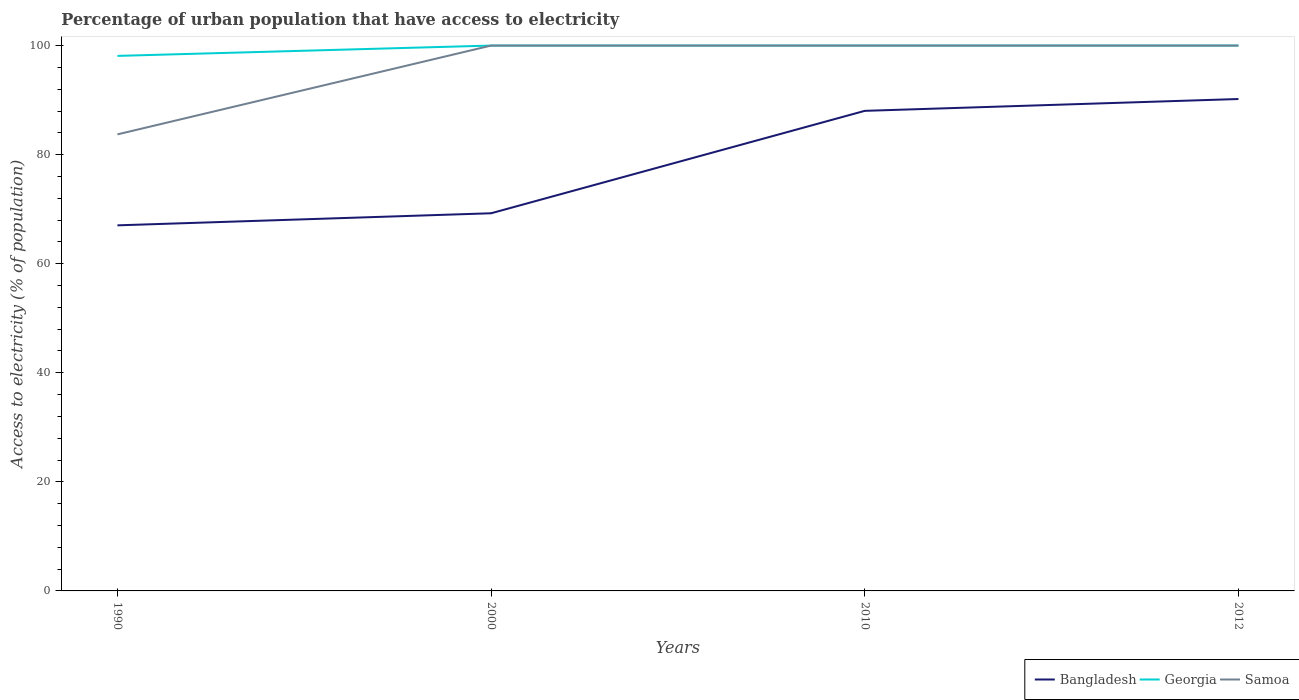How many different coloured lines are there?
Keep it short and to the point. 3. Does the line corresponding to Georgia intersect with the line corresponding to Samoa?
Offer a very short reply. Yes. Is the number of lines equal to the number of legend labels?
Ensure brevity in your answer.  Yes. Across all years, what is the maximum percentage of urban population that have access to electricity in Samoa?
Provide a succinct answer. 83.72. What is the total percentage of urban population that have access to electricity in Bangladesh in the graph?
Make the answer very short. -18.78. What is the difference between the highest and the second highest percentage of urban population that have access to electricity in Georgia?
Provide a succinct answer. 1.89. What is the difference between the highest and the lowest percentage of urban population that have access to electricity in Bangladesh?
Provide a succinct answer. 2. How many years are there in the graph?
Make the answer very short. 4. Does the graph contain any zero values?
Offer a very short reply. No. Where does the legend appear in the graph?
Offer a very short reply. Bottom right. How many legend labels are there?
Provide a short and direct response. 3. What is the title of the graph?
Offer a very short reply. Percentage of urban population that have access to electricity. Does "Channel Islands" appear as one of the legend labels in the graph?
Keep it short and to the point. No. What is the label or title of the X-axis?
Make the answer very short. Years. What is the label or title of the Y-axis?
Provide a short and direct response. Access to electricity (% of population). What is the Access to electricity (% of population) in Bangladesh in 1990?
Keep it short and to the point. 67.04. What is the Access to electricity (% of population) in Georgia in 1990?
Keep it short and to the point. 98.11. What is the Access to electricity (% of population) of Samoa in 1990?
Ensure brevity in your answer.  83.72. What is the Access to electricity (% of population) in Bangladesh in 2000?
Ensure brevity in your answer.  69.25. What is the Access to electricity (% of population) in Samoa in 2000?
Your response must be concise. 100. What is the Access to electricity (% of population) in Bangladesh in 2010?
Your answer should be compact. 88.03. What is the Access to electricity (% of population) of Bangladesh in 2012?
Keep it short and to the point. 90.2. What is the Access to electricity (% of population) in Samoa in 2012?
Ensure brevity in your answer.  100. Across all years, what is the maximum Access to electricity (% of population) of Bangladesh?
Your answer should be very brief. 90.2. Across all years, what is the maximum Access to electricity (% of population) of Georgia?
Give a very brief answer. 100. Across all years, what is the maximum Access to electricity (% of population) in Samoa?
Provide a succinct answer. 100. Across all years, what is the minimum Access to electricity (% of population) in Bangladesh?
Make the answer very short. 67.04. Across all years, what is the minimum Access to electricity (% of population) of Georgia?
Offer a terse response. 98.11. Across all years, what is the minimum Access to electricity (% of population) in Samoa?
Your response must be concise. 83.72. What is the total Access to electricity (% of population) of Bangladesh in the graph?
Give a very brief answer. 314.51. What is the total Access to electricity (% of population) in Georgia in the graph?
Keep it short and to the point. 398.11. What is the total Access to electricity (% of population) of Samoa in the graph?
Keep it short and to the point. 383.72. What is the difference between the Access to electricity (% of population) of Bangladesh in 1990 and that in 2000?
Your response must be concise. -2.21. What is the difference between the Access to electricity (% of population) of Georgia in 1990 and that in 2000?
Provide a succinct answer. -1.89. What is the difference between the Access to electricity (% of population) in Samoa in 1990 and that in 2000?
Make the answer very short. -16.28. What is the difference between the Access to electricity (% of population) in Bangladesh in 1990 and that in 2010?
Ensure brevity in your answer.  -20.99. What is the difference between the Access to electricity (% of population) in Georgia in 1990 and that in 2010?
Your answer should be compact. -1.89. What is the difference between the Access to electricity (% of population) in Samoa in 1990 and that in 2010?
Your response must be concise. -16.28. What is the difference between the Access to electricity (% of population) of Bangladesh in 1990 and that in 2012?
Give a very brief answer. -23.16. What is the difference between the Access to electricity (% of population) in Georgia in 1990 and that in 2012?
Give a very brief answer. -1.89. What is the difference between the Access to electricity (% of population) of Samoa in 1990 and that in 2012?
Provide a succinct answer. -16.28. What is the difference between the Access to electricity (% of population) of Bangladesh in 2000 and that in 2010?
Keep it short and to the point. -18.78. What is the difference between the Access to electricity (% of population) in Bangladesh in 2000 and that in 2012?
Your response must be concise. -20.95. What is the difference between the Access to electricity (% of population) of Samoa in 2000 and that in 2012?
Provide a short and direct response. 0. What is the difference between the Access to electricity (% of population) of Bangladesh in 2010 and that in 2012?
Your answer should be compact. -2.17. What is the difference between the Access to electricity (% of population) of Samoa in 2010 and that in 2012?
Keep it short and to the point. 0. What is the difference between the Access to electricity (% of population) of Bangladesh in 1990 and the Access to electricity (% of population) of Georgia in 2000?
Your answer should be compact. -32.96. What is the difference between the Access to electricity (% of population) in Bangladesh in 1990 and the Access to electricity (% of population) in Samoa in 2000?
Ensure brevity in your answer.  -32.96. What is the difference between the Access to electricity (% of population) in Georgia in 1990 and the Access to electricity (% of population) in Samoa in 2000?
Your response must be concise. -1.89. What is the difference between the Access to electricity (% of population) in Bangladesh in 1990 and the Access to electricity (% of population) in Georgia in 2010?
Provide a succinct answer. -32.96. What is the difference between the Access to electricity (% of population) in Bangladesh in 1990 and the Access to electricity (% of population) in Samoa in 2010?
Make the answer very short. -32.96. What is the difference between the Access to electricity (% of population) in Georgia in 1990 and the Access to electricity (% of population) in Samoa in 2010?
Give a very brief answer. -1.89. What is the difference between the Access to electricity (% of population) of Bangladesh in 1990 and the Access to electricity (% of population) of Georgia in 2012?
Keep it short and to the point. -32.96. What is the difference between the Access to electricity (% of population) in Bangladesh in 1990 and the Access to electricity (% of population) in Samoa in 2012?
Offer a terse response. -32.96. What is the difference between the Access to electricity (% of population) in Georgia in 1990 and the Access to electricity (% of population) in Samoa in 2012?
Offer a terse response. -1.89. What is the difference between the Access to electricity (% of population) in Bangladesh in 2000 and the Access to electricity (% of population) in Georgia in 2010?
Ensure brevity in your answer.  -30.75. What is the difference between the Access to electricity (% of population) in Bangladesh in 2000 and the Access to electricity (% of population) in Samoa in 2010?
Provide a short and direct response. -30.75. What is the difference between the Access to electricity (% of population) in Bangladesh in 2000 and the Access to electricity (% of population) in Georgia in 2012?
Ensure brevity in your answer.  -30.75. What is the difference between the Access to electricity (% of population) of Bangladesh in 2000 and the Access to electricity (% of population) of Samoa in 2012?
Offer a very short reply. -30.75. What is the difference between the Access to electricity (% of population) in Georgia in 2000 and the Access to electricity (% of population) in Samoa in 2012?
Give a very brief answer. 0. What is the difference between the Access to electricity (% of population) in Bangladesh in 2010 and the Access to electricity (% of population) in Georgia in 2012?
Your response must be concise. -11.97. What is the difference between the Access to electricity (% of population) in Bangladesh in 2010 and the Access to electricity (% of population) in Samoa in 2012?
Offer a terse response. -11.97. What is the difference between the Access to electricity (% of population) of Georgia in 2010 and the Access to electricity (% of population) of Samoa in 2012?
Your response must be concise. 0. What is the average Access to electricity (% of population) of Bangladesh per year?
Give a very brief answer. 78.63. What is the average Access to electricity (% of population) of Georgia per year?
Your answer should be very brief. 99.53. What is the average Access to electricity (% of population) of Samoa per year?
Your answer should be very brief. 95.93. In the year 1990, what is the difference between the Access to electricity (% of population) of Bangladesh and Access to electricity (% of population) of Georgia?
Give a very brief answer. -31.07. In the year 1990, what is the difference between the Access to electricity (% of population) in Bangladesh and Access to electricity (% of population) in Samoa?
Your answer should be very brief. -16.68. In the year 1990, what is the difference between the Access to electricity (% of population) of Georgia and Access to electricity (% of population) of Samoa?
Offer a terse response. 14.39. In the year 2000, what is the difference between the Access to electricity (% of population) of Bangladesh and Access to electricity (% of population) of Georgia?
Make the answer very short. -30.75. In the year 2000, what is the difference between the Access to electricity (% of population) in Bangladesh and Access to electricity (% of population) in Samoa?
Provide a succinct answer. -30.75. In the year 2010, what is the difference between the Access to electricity (% of population) in Bangladesh and Access to electricity (% of population) in Georgia?
Provide a short and direct response. -11.97. In the year 2010, what is the difference between the Access to electricity (% of population) in Bangladesh and Access to electricity (% of population) in Samoa?
Give a very brief answer. -11.97. In the year 2010, what is the difference between the Access to electricity (% of population) of Georgia and Access to electricity (% of population) of Samoa?
Offer a terse response. 0. In the year 2012, what is the difference between the Access to electricity (% of population) of Bangladesh and Access to electricity (% of population) of Georgia?
Your answer should be very brief. -9.8. In the year 2012, what is the difference between the Access to electricity (% of population) in Georgia and Access to electricity (% of population) in Samoa?
Give a very brief answer. 0. What is the ratio of the Access to electricity (% of population) in Bangladesh in 1990 to that in 2000?
Provide a short and direct response. 0.97. What is the ratio of the Access to electricity (% of population) in Georgia in 1990 to that in 2000?
Your answer should be compact. 0.98. What is the ratio of the Access to electricity (% of population) in Samoa in 1990 to that in 2000?
Offer a terse response. 0.84. What is the ratio of the Access to electricity (% of population) in Bangladesh in 1990 to that in 2010?
Offer a terse response. 0.76. What is the ratio of the Access to electricity (% of population) of Georgia in 1990 to that in 2010?
Keep it short and to the point. 0.98. What is the ratio of the Access to electricity (% of population) in Samoa in 1990 to that in 2010?
Provide a short and direct response. 0.84. What is the ratio of the Access to electricity (% of population) in Bangladesh in 1990 to that in 2012?
Your answer should be very brief. 0.74. What is the ratio of the Access to electricity (% of population) in Georgia in 1990 to that in 2012?
Provide a short and direct response. 0.98. What is the ratio of the Access to electricity (% of population) of Samoa in 1990 to that in 2012?
Offer a terse response. 0.84. What is the ratio of the Access to electricity (% of population) in Bangladesh in 2000 to that in 2010?
Offer a very short reply. 0.79. What is the ratio of the Access to electricity (% of population) in Samoa in 2000 to that in 2010?
Offer a very short reply. 1. What is the ratio of the Access to electricity (% of population) of Bangladesh in 2000 to that in 2012?
Keep it short and to the point. 0.77. What is the ratio of the Access to electricity (% of population) in Georgia in 2000 to that in 2012?
Ensure brevity in your answer.  1. What is the ratio of the Access to electricity (% of population) of Samoa in 2000 to that in 2012?
Provide a short and direct response. 1. What is the ratio of the Access to electricity (% of population) of Bangladesh in 2010 to that in 2012?
Your answer should be very brief. 0.98. What is the difference between the highest and the second highest Access to electricity (% of population) of Bangladesh?
Ensure brevity in your answer.  2.17. What is the difference between the highest and the second highest Access to electricity (% of population) in Georgia?
Provide a succinct answer. 0. What is the difference between the highest and the lowest Access to electricity (% of population) in Bangladesh?
Give a very brief answer. 23.16. What is the difference between the highest and the lowest Access to electricity (% of population) in Georgia?
Your answer should be compact. 1.89. What is the difference between the highest and the lowest Access to electricity (% of population) in Samoa?
Offer a very short reply. 16.28. 